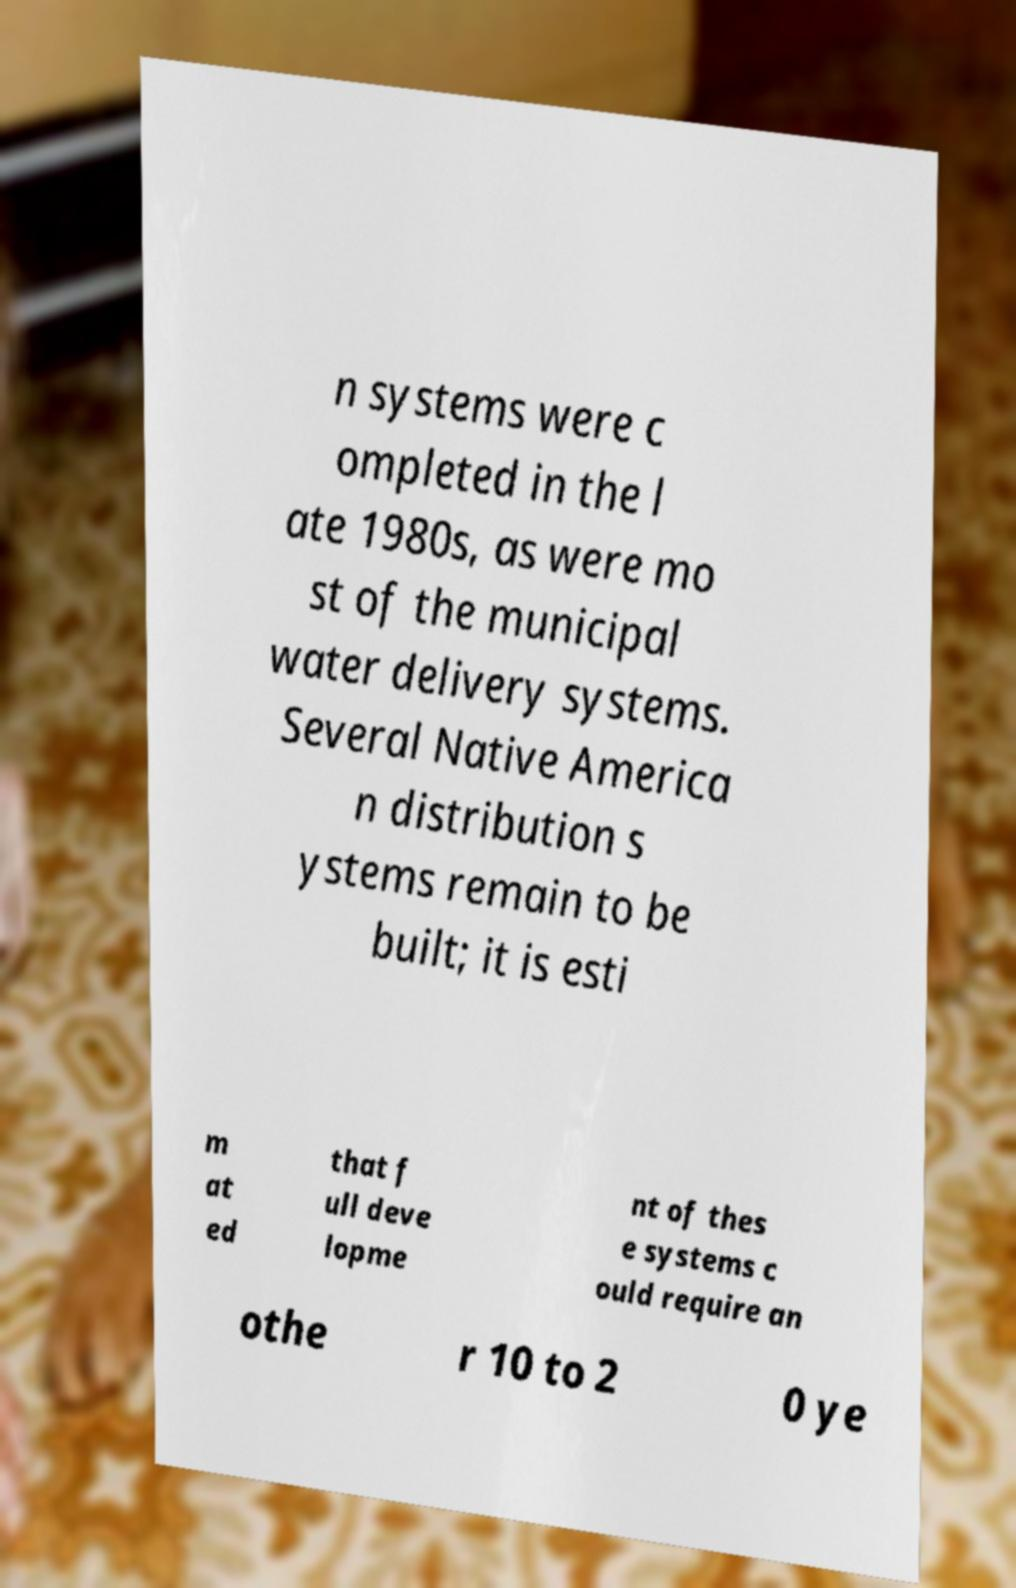What messages or text are displayed in this image? I need them in a readable, typed format. n systems were c ompleted in the l ate 1980s, as were mo st of the municipal water delivery systems. Several Native America n distribution s ystems remain to be built; it is esti m at ed that f ull deve lopme nt of thes e systems c ould require an othe r 10 to 2 0 ye 